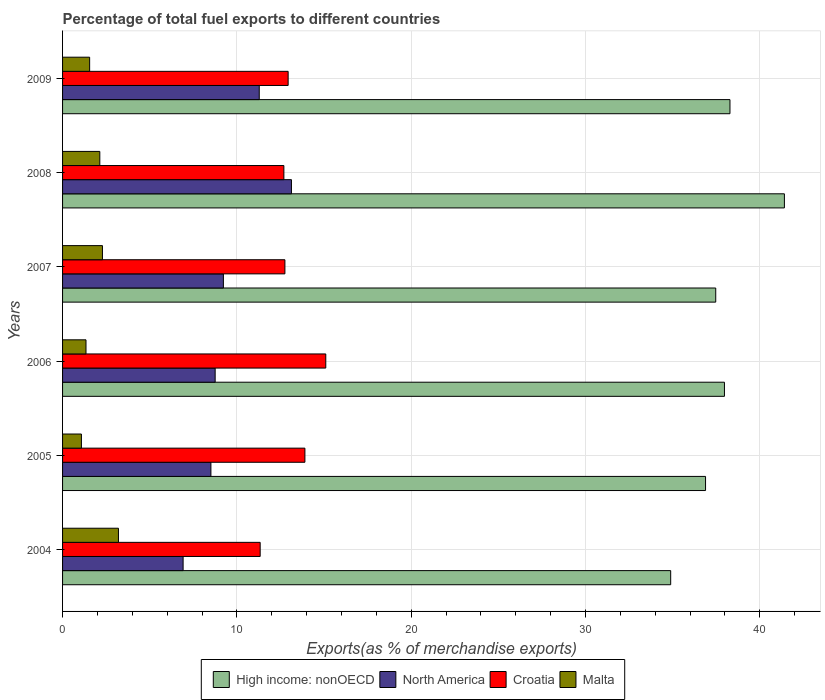How many different coloured bars are there?
Offer a terse response. 4. Are the number of bars per tick equal to the number of legend labels?
Your answer should be very brief. Yes. How many bars are there on the 2nd tick from the bottom?
Provide a short and direct response. 4. What is the percentage of exports to different countries in North America in 2006?
Your answer should be compact. 8.75. Across all years, what is the maximum percentage of exports to different countries in High income: nonOECD?
Offer a very short reply. 41.42. Across all years, what is the minimum percentage of exports to different countries in Malta?
Offer a terse response. 1.08. In which year was the percentage of exports to different countries in Croatia maximum?
Offer a very short reply. 2006. In which year was the percentage of exports to different countries in High income: nonOECD minimum?
Your answer should be very brief. 2004. What is the total percentage of exports to different countries in Croatia in the graph?
Offer a very short reply. 78.74. What is the difference between the percentage of exports to different countries in High income: nonOECD in 2005 and that in 2006?
Give a very brief answer. -1.08. What is the difference between the percentage of exports to different countries in High income: nonOECD in 2004 and the percentage of exports to different countries in Malta in 2007?
Offer a terse response. 32.6. What is the average percentage of exports to different countries in Croatia per year?
Your answer should be very brief. 13.12. In the year 2007, what is the difference between the percentage of exports to different countries in High income: nonOECD and percentage of exports to different countries in North America?
Offer a terse response. 28.25. What is the ratio of the percentage of exports to different countries in High income: nonOECD in 2004 to that in 2009?
Offer a very short reply. 0.91. Is the percentage of exports to different countries in North America in 2004 less than that in 2005?
Offer a terse response. Yes. Is the difference between the percentage of exports to different countries in High income: nonOECD in 2004 and 2005 greater than the difference between the percentage of exports to different countries in North America in 2004 and 2005?
Your answer should be very brief. No. What is the difference between the highest and the second highest percentage of exports to different countries in North America?
Provide a short and direct response. 1.85. What is the difference between the highest and the lowest percentage of exports to different countries in High income: nonOECD?
Keep it short and to the point. 6.52. What does the 2nd bar from the top in 2009 represents?
Your answer should be compact. Croatia. How many bars are there?
Give a very brief answer. 24. What is the difference between two consecutive major ticks on the X-axis?
Make the answer very short. 10. Are the values on the major ticks of X-axis written in scientific E-notation?
Ensure brevity in your answer.  No. Does the graph contain grids?
Give a very brief answer. Yes. What is the title of the graph?
Offer a very short reply. Percentage of total fuel exports to different countries. What is the label or title of the X-axis?
Give a very brief answer. Exports(as % of merchandise exports). What is the label or title of the Y-axis?
Offer a terse response. Years. What is the Exports(as % of merchandise exports) in High income: nonOECD in 2004?
Give a very brief answer. 34.89. What is the Exports(as % of merchandise exports) of North America in 2004?
Ensure brevity in your answer.  6.92. What is the Exports(as % of merchandise exports) in Croatia in 2004?
Your response must be concise. 11.34. What is the Exports(as % of merchandise exports) of Malta in 2004?
Your response must be concise. 3.21. What is the Exports(as % of merchandise exports) of High income: nonOECD in 2005?
Your answer should be very brief. 36.89. What is the Exports(as % of merchandise exports) of North America in 2005?
Your answer should be compact. 8.51. What is the Exports(as % of merchandise exports) of Croatia in 2005?
Your answer should be compact. 13.9. What is the Exports(as % of merchandise exports) of Malta in 2005?
Your answer should be very brief. 1.08. What is the Exports(as % of merchandise exports) of High income: nonOECD in 2006?
Ensure brevity in your answer.  37.98. What is the Exports(as % of merchandise exports) in North America in 2006?
Your response must be concise. 8.75. What is the Exports(as % of merchandise exports) of Croatia in 2006?
Provide a succinct answer. 15.1. What is the Exports(as % of merchandise exports) of Malta in 2006?
Offer a very short reply. 1.34. What is the Exports(as % of merchandise exports) of High income: nonOECD in 2007?
Offer a terse response. 37.48. What is the Exports(as % of merchandise exports) of North America in 2007?
Your answer should be very brief. 9.23. What is the Exports(as % of merchandise exports) in Croatia in 2007?
Offer a very short reply. 12.76. What is the Exports(as % of merchandise exports) in Malta in 2007?
Offer a very short reply. 2.29. What is the Exports(as % of merchandise exports) in High income: nonOECD in 2008?
Your response must be concise. 41.42. What is the Exports(as % of merchandise exports) in North America in 2008?
Provide a short and direct response. 13.13. What is the Exports(as % of merchandise exports) in Croatia in 2008?
Give a very brief answer. 12.7. What is the Exports(as % of merchandise exports) in Malta in 2008?
Give a very brief answer. 2.14. What is the Exports(as % of merchandise exports) in High income: nonOECD in 2009?
Offer a very short reply. 38.29. What is the Exports(as % of merchandise exports) in North America in 2009?
Your response must be concise. 11.28. What is the Exports(as % of merchandise exports) of Croatia in 2009?
Provide a short and direct response. 12.94. What is the Exports(as % of merchandise exports) in Malta in 2009?
Offer a very short reply. 1.55. Across all years, what is the maximum Exports(as % of merchandise exports) in High income: nonOECD?
Provide a short and direct response. 41.42. Across all years, what is the maximum Exports(as % of merchandise exports) in North America?
Your answer should be compact. 13.13. Across all years, what is the maximum Exports(as % of merchandise exports) in Croatia?
Your answer should be compact. 15.1. Across all years, what is the maximum Exports(as % of merchandise exports) of Malta?
Offer a very short reply. 3.21. Across all years, what is the minimum Exports(as % of merchandise exports) of High income: nonOECD?
Your answer should be compact. 34.89. Across all years, what is the minimum Exports(as % of merchandise exports) of North America?
Make the answer very short. 6.92. Across all years, what is the minimum Exports(as % of merchandise exports) in Croatia?
Your answer should be compact. 11.34. Across all years, what is the minimum Exports(as % of merchandise exports) in Malta?
Your answer should be very brief. 1.08. What is the total Exports(as % of merchandise exports) in High income: nonOECD in the graph?
Give a very brief answer. 226.94. What is the total Exports(as % of merchandise exports) of North America in the graph?
Your answer should be very brief. 57.83. What is the total Exports(as % of merchandise exports) of Croatia in the graph?
Provide a short and direct response. 78.74. What is the total Exports(as % of merchandise exports) in Malta in the graph?
Keep it short and to the point. 11.61. What is the difference between the Exports(as % of merchandise exports) of High income: nonOECD in 2004 and that in 2005?
Ensure brevity in your answer.  -2. What is the difference between the Exports(as % of merchandise exports) in North America in 2004 and that in 2005?
Give a very brief answer. -1.59. What is the difference between the Exports(as % of merchandise exports) in Croatia in 2004 and that in 2005?
Make the answer very short. -2.57. What is the difference between the Exports(as % of merchandise exports) of Malta in 2004 and that in 2005?
Your response must be concise. 2.13. What is the difference between the Exports(as % of merchandise exports) of High income: nonOECD in 2004 and that in 2006?
Your response must be concise. -3.08. What is the difference between the Exports(as % of merchandise exports) in North America in 2004 and that in 2006?
Your answer should be compact. -1.84. What is the difference between the Exports(as % of merchandise exports) in Croatia in 2004 and that in 2006?
Your answer should be compact. -3.77. What is the difference between the Exports(as % of merchandise exports) in Malta in 2004 and that in 2006?
Keep it short and to the point. 1.86. What is the difference between the Exports(as % of merchandise exports) of High income: nonOECD in 2004 and that in 2007?
Provide a succinct answer. -2.58. What is the difference between the Exports(as % of merchandise exports) of North America in 2004 and that in 2007?
Offer a terse response. -2.31. What is the difference between the Exports(as % of merchandise exports) in Croatia in 2004 and that in 2007?
Offer a very short reply. -1.42. What is the difference between the Exports(as % of merchandise exports) in Malta in 2004 and that in 2007?
Offer a terse response. 0.92. What is the difference between the Exports(as % of merchandise exports) in High income: nonOECD in 2004 and that in 2008?
Provide a succinct answer. -6.52. What is the difference between the Exports(as % of merchandise exports) of North America in 2004 and that in 2008?
Your response must be concise. -6.22. What is the difference between the Exports(as % of merchandise exports) of Croatia in 2004 and that in 2008?
Offer a terse response. -1.36. What is the difference between the Exports(as % of merchandise exports) of Malta in 2004 and that in 2008?
Provide a succinct answer. 1.07. What is the difference between the Exports(as % of merchandise exports) in High income: nonOECD in 2004 and that in 2009?
Offer a terse response. -3.4. What is the difference between the Exports(as % of merchandise exports) of North America in 2004 and that in 2009?
Provide a short and direct response. -4.37. What is the difference between the Exports(as % of merchandise exports) in Croatia in 2004 and that in 2009?
Provide a succinct answer. -1.6. What is the difference between the Exports(as % of merchandise exports) of Malta in 2004 and that in 2009?
Your answer should be very brief. 1.65. What is the difference between the Exports(as % of merchandise exports) in High income: nonOECD in 2005 and that in 2006?
Offer a terse response. -1.08. What is the difference between the Exports(as % of merchandise exports) in North America in 2005 and that in 2006?
Make the answer very short. -0.24. What is the difference between the Exports(as % of merchandise exports) of Croatia in 2005 and that in 2006?
Provide a succinct answer. -1.2. What is the difference between the Exports(as % of merchandise exports) of Malta in 2005 and that in 2006?
Your answer should be compact. -0.26. What is the difference between the Exports(as % of merchandise exports) of High income: nonOECD in 2005 and that in 2007?
Ensure brevity in your answer.  -0.58. What is the difference between the Exports(as % of merchandise exports) in North America in 2005 and that in 2007?
Provide a succinct answer. -0.72. What is the difference between the Exports(as % of merchandise exports) of Croatia in 2005 and that in 2007?
Ensure brevity in your answer.  1.15. What is the difference between the Exports(as % of merchandise exports) of Malta in 2005 and that in 2007?
Keep it short and to the point. -1.21. What is the difference between the Exports(as % of merchandise exports) in High income: nonOECD in 2005 and that in 2008?
Your answer should be compact. -4.52. What is the difference between the Exports(as % of merchandise exports) of North America in 2005 and that in 2008?
Your response must be concise. -4.62. What is the difference between the Exports(as % of merchandise exports) of Croatia in 2005 and that in 2008?
Provide a succinct answer. 1.21. What is the difference between the Exports(as % of merchandise exports) of Malta in 2005 and that in 2008?
Offer a very short reply. -1.06. What is the difference between the Exports(as % of merchandise exports) of High income: nonOECD in 2005 and that in 2009?
Offer a terse response. -1.4. What is the difference between the Exports(as % of merchandise exports) in North America in 2005 and that in 2009?
Ensure brevity in your answer.  -2.77. What is the difference between the Exports(as % of merchandise exports) in Croatia in 2005 and that in 2009?
Provide a succinct answer. 0.96. What is the difference between the Exports(as % of merchandise exports) of Malta in 2005 and that in 2009?
Offer a very short reply. -0.47. What is the difference between the Exports(as % of merchandise exports) of High income: nonOECD in 2006 and that in 2007?
Your response must be concise. 0.5. What is the difference between the Exports(as % of merchandise exports) in North America in 2006 and that in 2007?
Offer a terse response. -0.47. What is the difference between the Exports(as % of merchandise exports) of Croatia in 2006 and that in 2007?
Provide a succinct answer. 2.35. What is the difference between the Exports(as % of merchandise exports) of Malta in 2006 and that in 2007?
Make the answer very short. -0.94. What is the difference between the Exports(as % of merchandise exports) in High income: nonOECD in 2006 and that in 2008?
Your answer should be very brief. -3.44. What is the difference between the Exports(as % of merchandise exports) of North America in 2006 and that in 2008?
Keep it short and to the point. -4.38. What is the difference between the Exports(as % of merchandise exports) of Croatia in 2006 and that in 2008?
Offer a terse response. 2.4. What is the difference between the Exports(as % of merchandise exports) in Malta in 2006 and that in 2008?
Your answer should be very brief. -0.79. What is the difference between the Exports(as % of merchandise exports) in High income: nonOECD in 2006 and that in 2009?
Keep it short and to the point. -0.32. What is the difference between the Exports(as % of merchandise exports) of North America in 2006 and that in 2009?
Your answer should be very brief. -2.53. What is the difference between the Exports(as % of merchandise exports) of Croatia in 2006 and that in 2009?
Your response must be concise. 2.16. What is the difference between the Exports(as % of merchandise exports) of Malta in 2006 and that in 2009?
Ensure brevity in your answer.  -0.21. What is the difference between the Exports(as % of merchandise exports) of High income: nonOECD in 2007 and that in 2008?
Provide a succinct answer. -3.94. What is the difference between the Exports(as % of merchandise exports) of North America in 2007 and that in 2008?
Offer a terse response. -3.9. What is the difference between the Exports(as % of merchandise exports) of Croatia in 2007 and that in 2008?
Your answer should be very brief. 0.06. What is the difference between the Exports(as % of merchandise exports) in Malta in 2007 and that in 2008?
Provide a succinct answer. 0.15. What is the difference between the Exports(as % of merchandise exports) of High income: nonOECD in 2007 and that in 2009?
Make the answer very short. -0.82. What is the difference between the Exports(as % of merchandise exports) of North America in 2007 and that in 2009?
Keep it short and to the point. -2.06. What is the difference between the Exports(as % of merchandise exports) in Croatia in 2007 and that in 2009?
Offer a terse response. -0.19. What is the difference between the Exports(as % of merchandise exports) in Malta in 2007 and that in 2009?
Keep it short and to the point. 0.74. What is the difference between the Exports(as % of merchandise exports) in High income: nonOECD in 2008 and that in 2009?
Ensure brevity in your answer.  3.12. What is the difference between the Exports(as % of merchandise exports) of North America in 2008 and that in 2009?
Provide a succinct answer. 1.85. What is the difference between the Exports(as % of merchandise exports) in Croatia in 2008 and that in 2009?
Keep it short and to the point. -0.24. What is the difference between the Exports(as % of merchandise exports) of Malta in 2008 and that in 2009?
Offer a terse response. 0.58. What is the difference between the Exports(as % of merchandise exports) of High income: nonOECD in 2004 and the Exports(as % of merchandise exports) of North America in 2005?
Provide a short and direct response. 26.38. What is the difference between the Exports(as % of merchandise exports) in High income: nonOECD in 2004 and the Exports(as % of merchandise exports) in Croatia in 2005?
Your answer should be compact. 20.99. What is the difference between the Exports(as % of merchandise exports) in High income: nonOECD in 2004 and the Exports(as % of merchandise exports) in Malta in 2005?
Keep it short and to the point. 33.81. What is the difference between the Exports(as % of merchandise exports) of North America in 2004 and the Exports(as % of merchandise exports) of Croatia in 2005?
Ensure brevity in your answer.  -6.99. What is the difference between the Exports(as % of merchandise exports) in North America in 2004 and the Exports(as % of merchandise exports) in Malta in 2005?
Give a very brief answer. 5.83. What is the difference between the Exports(as % of merchandise exports) of Croatia in 2004 and the Exports(as % of merchandise exports) of Malta in 2005?
Offer a terse response. 10.26. What is the difference between the Exports(as % of merchandise exports) in High income: nonOECD in 2004 and the Exports(as % of merchandise exports) in North America in 2006?
Provide a succinct answer. 26.14. What is the difference between the Exports(as % of merchandise exports) in High income: nonOECD in 2004 and the Exports(as % of merchandise exports) in Croatia in 2006?
Provide a succinct answer. 19.79. What is the difference between the Exports(as % of merchandise exports) in High income: nonOECD in 2004 and the Exports(as % of merchandise exports) in Malta in 2006?
Ensure brevity in your answer.  33.55. What is the difference between the Exports(as % of merchandise exports) in North America in 2004 and the Exports(as % of merchandise exports) in Croatia in 2006?
Your response must be concise. -8.19. What is the difference between the Exports(as % of merchandise exports) in North America in 2004 and the Exports(as % of merchandise exports) in Malta in 2006?
Keep it short and to the point. 5.57. What is the difference between the Exports(as % of merchandise exports) of Croatia in 2004 and the Exports(as % of merchandise exports) of Malta in 2006?
Offer a very short reply. 9.99. What is the difference between the Exports(as % of merchandise exports) of High income: nonOECD in 2004 and the Exports(as % of merchandise exports) of North America in 2007?
Provide a succinct answer. 25.66. What is the difference between the Exports(as % of merchandise exports) of High income: nonOECD in 2004 and the Exports(as % of merchandise exports) of Croatia in 2007?
Ensure brevity in your answer.  22.14. What is the difference between the Exports(as % of merchandise exports) of High income: nonOECD in 2004 and the Exports(as % of merchandise exports) of Malta in 2007?
Give a very brief answer. 32.6. What is the difference between the Exports(as % of merchandise exports) of North America in 2004 and the Exports(as % of merchandise exports) of Croatia in 2007?
Keep it short and to the point. -5.84. What is the difference between the Exports(as % of merchandise exports) of North America in 2004 and the Exports(as % of merchandise exports) of Malta in 2007?
Provide a short and direct response. 4.63. What is the difference between the Exports(as % of merchandise exports) in Croatia in 2004 and the Exports(as % of merchandise exports) in Malta in 2007?
Keep it short and to the point. 9.05. What is the difference between the Exports(as % of merchandise exports) of High income: nonOECD in 2004 and the Exports(as % of merchandise exports) of North America in 2008?
Your response must be concise. 21.76. What is the difference between the Exports(as % of merchandise exports) of High income: nonOECD in 2004 and the Exports(as % of merchandise exports) of Croatia in 2008?
Ensure brevity in your answer.  22.19. What is the difference between the Exports(as % of merchandise exports) in High income: nonOECD in 2004 and the Exports(as % of merchandise exports) in Malta in 2008?
Ensure brevity in your answer.  32.75. What is the difference between the Exports(as % of merchandise exports) in North America in 2004 and the Exports(as % of merchandise exports) in Croatia in 2008?
Provide a short and direct response. -5.78. What is the difference between the Exports(as % of merchandise exports) of North America in 2004 and the Exports(as % of merchandise exports) of Malta in 2008?
Give a very brief answer. 4.78. What is the difference between the Exports(as % of merchandise exports) in Croatia in 2004 and the Exports(as % of merchandise exports) in Malta in 2008?
Give a very brief answer. 9.2. What is the difference between the Exports(as % of merchandise exports) of High income: nonOECD in 2004 and the Exports(as % of merchandise exports) of North America in 2009?
Offer a terse response. 23.61. What is the difference between the Exports(as % of merchandise exports) in High income: nonOECD in 2004 and the Exports(as % of merchandise exports) in Croatia in 2009?
Keep it short and to the point. 21.95. What is the difference between the Exports(as % of merchandise exports) of High income: nonOECD in 2004 and the Exports(as % of merchandise exports) of Malta in 2009?
Your response must be concise. 33.34. What is the difference between the Exports(as % of merchandise exports) of North America in 2004 and the Exports(as % of merchandise exports) of Croatia in 2009?
Give a very brief answer. -6.03. What is the difference between the Exports(as % of merchandise exports) in North America in 2004 and the Exports(as % of merchandise exports) in Malta in 2009?
Provide a short and direct response. 5.36. What is the difference between the Exports(as % of merchandise exports) of Croatia in 2004 and the Exports(as % of merchandise exports) of Malta in 2009?
Your answer should be very brief. 9.78. What is the difference between the Exports(as % of merchandise exports) of High income: nonOECD in 2005 and the Exports(as % of merchandise exports) of North America in 2006?
Your response must be concise. 28.14. What is the difference between the Exports(as % of merchandise exports) in High income: nonOECD in 2005 and the Exports(as % of merchandise exports) in Croatia in 2006?
Offer a terse response. 21.79. What is the difference between the Exports(as % of merchandise exports) of High income: nonOECD in 2005 and the Exports(as % of merchandise exports) of Malta in 2006?
Give a very brief answer. 35.55. What is the difference between the Exports(as % of merchandise exports) of North America in 2005 and the Exports(as % of merchandise exports) of Croatia in 2006?
Provide a succinct answer. -6.59. What is the difference between the Exports(as % of merchandise exports) of North America in 2005 and the Exports(as % of merchandise exports) of Malta in 2006?
Make the answer very short. 7.17. What is the difference between the Exports(as % of merchandise exports) in Croatia in 2005 and the Exports(as % of merchandise exports) in Malta in 2006?
Provide a short and direct response. 12.56. What is the difference between the Exports(as % of merchandise exports) in High income: nonOECD in 2005 and the Exports(as % of merchandise exports) in North America in 2007?
Make the answer very short. 27.66. What is the difference between the Exports(as % of merchandise exports) of High income: nonOECD in 2005 and the Exports(as % of merchandise exports) of Croatia in 2007?
Your response must be concise. 24.13. What is the difference between the Exports(as % of merchandise exports) of High income: nonOECD in 2005 and the Exports(as % of merchandise exports) of Malta in 2007?
Offer a terse response. 34.6. What is the difference between the Exports(as % of merchandise exports) in North America in 2005 and the Exports(as % of merchandise exports) in Croatia in 2007?
Provide a succinct answer. -4.25. What is the difference between the Exports(as % of merchandise exports) in North America in 2005 and the Exports(as % of merchandise exports) in Malta in 2007?
Your answer should be compact. 6.22. What is the difference between the Exports(as % of merchandise exports) in Croatia in 2005 and the Exports(as % of merchandise exports) in Malta in 2007?
Your answer should be compact. 11.62. What is the difference between the Exports(as % of merchandise exports) of High income: nonOECD in 2005 and the Exports(as % of merchandise exports) of North America in 2008?
Provide a short and direct response. 23.76. What is the difference between the Exports(as % of merchandise exports) of High income: nonOECD in 2005 and the Exports(as % of merchandise exports) of Croatia in 2008?
Keep it short and to the point. 24.19. What is the difference between the Exports(as % of merchandise exports) in High income: nonOECD in 2005 and the Exports(as % of merchandise exports) in Malta in 2008?
Offer a very short reply. 34.75. What is the difference between the Exports(as % of merchandise exports) in North America in 2005 and the Exports(as % of merchandise exports) in Croatia in 2008?
Your response must be concise. -4.19. What is the difference between the Exports(as % of merchandise exports) of North America in 2005 and the Exports(as % of merchandise exports) of Malta in 2008?
Your answer should be compact. 6.37. What is the difference between the Exports(as % of merchandise exports) in Croatia in 2005 and the Exports(as % of merchandise exports) in Malta in 2008?
Your answer should be very brief. 11.77. What is the difference between the Exports(as % of merchandise exports) in High income: nonOECD in 2005 and the Exports(as % of merchandise exports) in North America in 2009?
Ensure brevity in your answer.  25.61. What is the difference between the Exports(as % of merchandise exports) of High income: nonOECD in 2005 and the Exports(as % of merchandise exports) of Croatia in 2009?
Provide a short and direct response. 23.95. What is the difference between the Exports(as % of merchandise exports) of High income: nonOECD in 2005 and the Exports(as % of merchandise exports) of Malta in 2009?
Offer a very short reply. 35.34. What is the difference between the Exports(as % of merchandise exports) of North America in 2005 and the Exports(as % of merchandise exports) of Croatia in 2009?
Keep it short and to the point. -4.43. What is the difference between the Exports(as % of merchandise exports) in North America in 2005 and the Exports(as % of merchandise exports) in Malta in 2009?
Ensure brevity in your answer.  6.96. What is the difference between the Exports(as % of merchandise exports) in Croatia in 2005 and the Exports(as % of merchandise exports) in Malta in 2009?
Ensure brevity in your answer.  12.35. What is the difference between the Exports(as % of merchandise exports) of High income: nonOECD in 2006 and the Exports(as % of merchandise exports) of North America in 2007?
Provide a short and direct response. 28.75. What is the difference between the Exports(as % of merchandise exports) of High income: nonOECD in 2006 and the Exports(as % of merchandise exports) of Croatia in 2007?
Keep it short and to the point. 25.22. What is the difference between the Exports(as % of merchandise exports) of High income: nonOECD in 2006 and the Exports(as % of merchandise exports) of Malta in 2007?
Offer a very short reply. 35.69. What is the difference between the Exports(as % of merchandise exports) in North America in 2006 and the Exports(as % of merchandise exports) in Croatia in 2007?
Ensure brevity in your answer.  -4. What is the difference between the Exports(as % of merchandise exports) of North America in 2006 and the Exports(as % of merchandise exports) of Malta in 2007?
Provide a succinct answer. 6.47. What is the difference between the Exports(as % of merchandise exports) of Croatia in 2006 and the Exports(as % of merchandise exports) of Malta in 2007?
Provide a short and direct response. 12.81. What is the difference between the Exports(as % of merchandise exports) in High income: nonOECD in 2006 and the Exports(as % of merchandise exports) in North America in 2008?
Provide a short and direct response. 24.84. What is the difference between the Exports(as % of merchandise exports) of High income: nonOECD in 2006 and the Exports(as % of merchandise exports) of Croatia in 2008?
Give a very brief answer. 25.28. What is the difference between the Exports(as % of merchandise exports) of High income: nonOECD in 2006 and the Exports(as % of merchandise exports) of Malta in 2008?
Ensure brevity in your answer.  35.84. What is the difference between the Exports(as % of merchandise exports) in North America in 2006 and the Exports(as % of merchandise exports) in Croatia in 2008?
Your response must be concise. -3.94. What is the difference between the Exports(as % of merchandise exports) of North America in 2006 and the Exports(as % of merchandise exports) of Malta in 2008?
Your response must be concise. 6.62. What is the difference between the Exports(as % of merchandise exports) of Croatia in 2006 and the Exports(as % of merchandise exports) of Malta in 2008?
Offer a terse response. 12.97. What is the difference between the Exports(as % of merchandise exports) of High income: nonOECD in 2006 and the Exports(as % of merchandise exports) of North America in 2009?
Provide a succinct answer. 26.69. What is the difference between the Exports(as % of merchandise exports) in High income: nonOECD in 2006 and the Exports(as % of merchandise exports) in Croatia in 2009?
Your response must be concise. 25.03. What is the difference between the Exports(as % of merchandise exports) in High income: nonOECD in 2006 and the Exports(as % of merchandise exports) in Malta in 2009?
Make the answer very short. 36.42. What is the difference between the Exports(as % of merchandise exports) of North America in 2006 and the Exports(as % of merchandise exports) of Croatia in 2009?
Your answer should be very brief. -4.19. What is the difference between the Exports(as % of merchandise exports) of North America in 2006 and the Exports(as % of merchandise exports) of Malta in 2009?
Keep it short and to the point. 7.2. What is the difference between the Exports(as % of merchandise exports) in Croatia in 2006 and the Exports(as % of merchandise exports) in Malta in 2009?
Provide a short and direct response. 13.55. What is the difference between the Exports(as % of merchandise exports) of High income: nonOECD in 2007 and the Exports(as % of merchandise exports) of North America in 2008?
Your answer should be compact. 24.34. What is the difference between the Exports(as % of merchandise exports) of High income: nonOECD in 2007 and the Exports(as % of merchandise exports) of Croatia in 2008?
Your answer should be very brief. 24.78. What is the difference between the Exports(as % of merchandise exports) of High income: nonOECD in 2007 and the Exports(as % of merchandise exports) of Malta in 2008?
Your answer should be compact. 35.34. What is the difference between the Exports(as % of merchandise exports) of North America in 2007 and the Exports(as % of merchandise exports) of Croatia in 2008?
Offer a terse response. -3.47. What is the difference between the Exports(as % of merchandise exports) of North America in 2007 and the Exports(as % of merchandise exports) of Malta in 2008?
Ensure brevity in your answer.  7.09. What is the difference between the Exports(as % of merchandise exports) in Croatia in 2007 and the Exports(as % of merchandise exports) in Malta in 2008?
Keep it short and to the point. 10.62. What is the difference between the Exports(as % of merchandise exports) of High income: nonOECD in 2007 and the Exports(as % of merchandise exports) of North America in 2009?
Give a very brief answer. 26.19. What is the difference between the Exports(as % of merchandise exports) in High income: nonOECD in 2007 and the Exports(as % of merchandise exports) in Croatia in 2009?
Ensure brevity in your answer.  24.53. What is the difference between the Exports(as % of merchandise exports) of High income: nonOECD in 2007 and the Exports(as % of merchandise exports) of Malta in 2009?
Make the answer very short. 35.92. What is the difference between the Exports(as % of merchandise exports) of North America in 2007 and the Exports(as % of merchandise exports) of Croatia in 2009?
Your answer should be very brief. -3.71. What is the difference between the Exports(as % of merchandise exports) in North America in 2007 and the Exports(as % of merchandise exports) in Malta in 2009?
Provide a succinct answer. 7.67. What is the difference between the Exports(as % of merchandise exports) in Croatia in 2007 and the Exports(as % of merchandise exports) in Malta in 2009?
Make the answer very short. 11.2. What is the difference between the Exports(as % of merchandise exports) in High income: nonOECD in 2008 and the Exports(as % of merchandise exports) in North America in 2009?
Give a very brief answer. 30.13. What is the difference between the Exports(as % of merchandise exports) in High income: nonOECD in 2008 and the Exports(as % of merchandise exports) in Croatia in 2009?
Ensure brevity in your answer.  28.47. What is the difference between the Exports(as % of merchandise exports) in High income: nonOECD in 2008 and the Exports(as % of merchandise exports) in Malta in 2009?
Provide a succinct answer. 39.86. What is the difference between the Exports(as % of merchandise exports) of North America in 2008 and the Exports(as % of merchandise exports) of Croatia in 2009?
Provide a short and direct response. 0.19. What is the difference between the Exports(as % of merchandise exports) of North America in 2008 and the Exports(as % of merchandise exports) of Malta in 2009?
Make the answer very short. 11.58. What is the difference between the Exports(as % of merchandise exports) of Croatia in 2008 and the Exports(as % of merchandise exports) of Malta in 2009?
Offer a very short reply. 11.14. What is the average Exports(as % of merchandise exports) in High income: nonOECD per year?
Ensure brevity in your answer.  37.82. What is the average Exports(as % of merchandise exports) of North America per year?
Provide a succinct answer. 9.64. What is the average Exports(as % of merchandise exports) in Croatia per year?
Provide a succinct answer. 13.12. What is the average Exports(as % of merchandise exports) in Malta per year?
Give a very brief answer. 1.94. In the year 2004, what is the difference between the Exports(as % of merchandise exports) of High income: nonOECD and Exports(as % of merchandise exports) of North America?
Your answer should be very brief. 27.98. In the year 2004, what is the difference between the Exports(as % of merchandise exports) of High income: nonOECD and Exports(as % of merchandise exports) of Croatia?
Provide a succinct answer. 23.55. In the year 2004, what is the difference between the Exports(as % of merchandise exports) in High income: nonOECD and Exports(as % of merchandise exports) in Malta?
Provide a short and direct response. 31.69. In the year 2004, what is the difference between the Exports(as % of merchandise exports) in North America and Exports(as % of merchandise exports) in Croatia?
Provide a short and direct response. -4.42. In the year 2004, what is the difference between the Exports(as % of merchandise exports) of North America and Exports(as % of merchandise exports) of Malta?
Provide a short and direct response. 3.71. In the year 2004, what is the difference between the Exports(as % of merchandise exports) of Croatia and Exports(as % of merchandise exports) of Malta?
Your answer should be very brief. 8.13. In the year 2005, what is the difference between the Exports(as % of merchandise exports) in High income: nonOECD and Exports(as % of merchandise exports) in North America?
Your answer should be compact. 28.38. In the year 2005, what is the difference between the Exports(as % of merchandise exports) in High income: nonOECD and Exports(as % of merchandise exports) in Croatia?
Provide a short and direct response. 22.99. In the year 2005, what is the difference between the Exports(as % of merchandise exports) in High income: nonOECD and Exports(as % of merchandise exports) in Malta?
Ensure brevity in your answer.  35.81. In the year 2005, what is the difference between the Exports(as % of merchandise exports) of North America and Exports(as % of merchandise exports) of Croatia?
Keep it short and to the point. -5.39. In the year 2005, what is the difference between the Exports(as % of merchandise exports) in North America and Exports(as % of merchandise exports) in Malta?
Ensure brevity in your answer.  7.43. In the year 2005, what is the difference between the Exports(as % of merchandise exports) in Croatia and Exports(as % of merchandise exports) in Malta?
Your answer should be compact. 12.82. In the year 2006, what is the difference between the Exports(as % of merchandise exports) of High income: nonOECD and Exports(as % of merchandise exports) of North America?
Your response must be concise. 29.22. In the year 2006, what is the difference between the Exports(as % of merchandise exports) of High income: nonOECD and Exports(as % of merchandise exports) of Croatia?
Provide a succinct answer. 22.87. In the year 2006, what is the difference between the Exports(as % of merchandise exports) of High income: nonOECD and Exports(as % of merchandise exports) of Malta?
Offer a terse response. 36.63. In the year 2006, what is the difference between the Exports(as % of merchandise exports) of North America and Exports(as % of merchandise exports) of Croatia?
Ensure brevity in your answer.  -6.35. In the year 2006, what is the difference between the Exports(as % of merchandise exports) in North America and Exports(as % of merchandise exports) in Malta?
Your answer should be compact. 7.41. In the year 2006, what is the difference between the Exports(as % of merchandise exports) of Croatia and Exports(as % of merchandise exports) of Malta?
Ensure brevity in your answer.  13.76. In the year 2007, what is the difference between the Exports(as % of merchandise exports) of High income: nonOECD and Exports(as % of merchandise exports) of North America?
Make the answer very short. 28.25. In the year 2007, what is the difference between the Exports(as % of merchandise exports) in High income: nonOECD and Exports(as % of merchandise exports) in Croatia?
Give a very brief answer. 24.72. In the year 2007, what is the difference between the Exports(as % of merchandise exports) of High income: nonOECD and Exports(as % of merchandise exports) of Malta?
Give a very brief answer. 35.19. In the year 2007, what is the difference between the Exports(as % of merchandise exports) of North America and Exports(as % of merchandise exports) of Croatia?
Keep it short and to the point. -3.53. In the year 2007, what is the difference between the Exports(as % of merchandise exports) of North America and Exports(as % of merchandise exports) of Malta?
Keep it short and to the point. 6.94. In the year 2007, what is the difference between the Exports(as % of merchandise exports) of Croatia and Exports(as % of merchandise exports) of Malta?
Offer a terse response. 10.47. In the year 2008, what is the difference between the Exports(as % of merchandise exports) of High income: nonOECD and Exports(as % of merchandise exports) of North America?
Ensure brevity in your answer.  28.28. In the year 2008, what is the difference between the Exports(as % of merchandise exports) of High income: nonOECD and Exports(as % of merchandise exports) of Croatia?
Make the answer very short. 28.72. In the year 2008, what is the difference between the Exports(as % of merchandise exports) in High income: nonOECD and Exports(as % of merchandise exports) in Malta?
Keep it short and to the point. 39.28. In the year 2008, what is the difference between the Exports(as % of merchandise exports) of North America and Exports(as % of merchandise exports) of Croatia?
Offer a terse response. 0.43. In the year 2008, what is the difference between the Exports(as % of merchandise exports) in North America and Exports(as % of merchandise exports) in Malta?
Provide a succinct answer. 11. In the year 2008, what is the difference between the Exports(as % of merchandise exports) in Croatia and Exports(as % of merchandise exports) in Malta?
Provide a short and direct response. 10.56. In the year 2009, what is the difference between the Exports(as % of merchandise exports) of High income: nonOECD and Exports(as % of merchandise exports) of North America?
Keep it short and to the point. 27.01. In the year 2009, what is the difference between the Exports(as % of merchandise exports) in High income: nonOECD and Exports(as % of merchandise exports) in Croatia?
Keep it short and to the point. 25.35. In the year 2009, what is the difference between the Exports(as % of merchandise exports) of High income: nonOECD and Exports(as % of merchandise exports) of Malta?
Your answer should be very brief. 36.74. In the year 2009, what is the difference between the Exports(as % of merchandise exports) in North America and Exports(as % of merchandise exports) in Croatia?
Offer a terse response. -1.66. In the year 2009, what is the difference between the Exports(as % of merchandise exports) in North America and Exports(as % of merchandise exports) in Malta?
Your answer should be compact. 9.73. In the year 2009, what is the difference between the Exports(as % of merchandise exports) of Croatia and Exports(as % of merchandise exports) of Malta?
Provide a short and direct response. 11.39. What is the ratio of the Exports(as % of merchandise exports) in High income: nonOECD in 2004 to that in 2005?
Your answer should be very brief. 0.95. What is the ratio of the Exports(as % of merchandise exports) of North America in 2004 to that in 2005?
Provide a short and direct response. 0.81. What is the ratio of the Exports(as % of merchandise exports) in Croatia in 2004 to that in 2005?
Offer a very short reply. 0.82. What is the ratio of the Exports(as % of merchandise exports) in Malta in 2004 to that in 2005?
Provide a short and direct response. 2.96. What is the ratio of the Exports(as % of merchandise exports) in High income: nonOECD in 2004 to that in 2006?
Provide a succinct answer. 0.92. What is the ratio of the Exports(as % of merchandise exports) of North America in 2004 to that in 2006?
Provide a succinct answer. 0.79. What is the ratio of the Exports(as % of merchandise exports) in Croatia in 2004 to that in 2006?
Make the answer very short. 0.75. What is the ratio of the Exports(as % of merchandise exports) in Malta in 2004 to that in 2006?
Your answer should be very brief. 2.38. What is the ratio of the Exports(as % of merchandise exports) in High income: nonOECD in 2004 to that in 2007?
Give a very brief answer. 0.93. What is the ratio of the Exports(as % of merchandise exports) in North America in 2004 to that in 2007?
Make the answer very short. 0.75. What is the ratio of the Exports(as % of merchandise exports) in Croatia in 2004 to that in 2007?
Keep it short and to the point. 0.89. What is the ratio of the Exports(as % of merchandise exports) in Malta in 2004 to that in 2007?
Your answer should be compact. 1.4. What is the ratio of the Exports(as % of merchandise exports) of High income: nonOECD in 2004 to that in 2008?
Make the answer very short. 0.84. What is the ratio of the Exports(as % of merchandise exports) of North America in 2004 to that in 2008?
Make the answer very short. 0.53. What is the ratio of the Exports(as % of merchandise exports) of Croatia in 2004 to that in 2008?
Keep it short and to the point. 0.89. What is the ratio of the Exports(as % of merchandise exports) of Malta in 2004 to that in 2008?
Keep it short and to the point. 1.5. What is the ratio of the Exports(as % of merchandise exports) in High income: nonOECD in 2004 to that in 2009?
Provide a succinct answer. 0.91. What is the ratio of the Exports(as % of merchandise exports) of North America in 2004 to that in 2009?
Provide a short and direct response. 0.61. What is the ratio of the Exports(as % of merchandise exports) in Croatia in 2004 to that in 2009?
Provide a succinct answer. 0.88. What is the ratio of the Exports(as % of merchandise exports) in Malta in 2004 to that in 2009?
Offer a terse response. 2.06. What is the ratio of the Exports(as % of merchandise exports) of High income: nonOECD in 2005 to that in 2006?
Your answer should be very brief. 0.97. What is the ratio of the Exports(as % of merchandise exports) in North America in 2005 to that in 2006?
Keep it short and to the point. 0.97. What is the ratio of the Exports(as % of merchandise exports) of Croatia in 2005 to that in 2006?
Offer a very short reply. 0.92. What is the ratio of the Exports(as % of merchandise exports) in Malta in 2005 to that in 2006?
Provide a short and direct response. 0.8. What is the ratio of the Exports(as % of merchandise exports) of High income: nonOECD in 2005 to that in 2007?
Keep it short and to the point. 0.98. What is the ratio of the Exports(as % of merchandise exports) of North America in 2005 to that in 2007?
Offer a very short reply. 0.92. What is the ratio of the Exports(as % of merchandise exports) in Croatia in 2005 to that in 2007?
Give a very brief answer. 1.09. What is the ratio of the Exports(as % of merchandise exports) of Malta in 2005 to that in 2007?
Ensure brevity in your answer.  0.47. What is the ratio of the Exports(as % of merchandise exports) in High income: nonOECD in 2005 to that in 2008?
Keep it short and to the point. 0.89. What is the ratio of the Exports(as % of merchandise exports) of North America in 2005 to that in 2008?
Provide a short and direct response. 0.65. What is the ratio of the Exports(as % of merchandise exports) of Croatia in 2005 to that in 2008?
Your answer should be very brief. 1.09. What is the ratio of the Exports(as % of merchandise exports) of Malta in 2005 to that in 2008?
Make the answer very short. 0.51. What is the ratio of the Exports(as % of merchandise exports) in High income: nonOECD in 2005 to that in 2009?
Your answer should be very brief. 0.96. What is the ratio of the Exports(as % of merchandise exports) in North America in 2005 to that in 2009?
Provide a succinct answer. 0.75. What is the ratio of the Exports(as % of merchandise exports) of Croatia in 2005 to that in 2009?
Offer a terse response. 1.07. What is the ratio of the Exports(as % of merchandise exports) in Malta in 2005 to that in 2009?
Provide a succinct answer. 0.7. What is the ratio of the Exports(as % of merchandise exports) in High income: nonOECD in 2006 to that in 2007?
Provide a short and direct response. 1.01. What is the ratio of the Exports(as % of merchandise exports) of North America in 2006 to that in 2007?
Make the answer very short. 0.95. What is the ratio of the Exports(as % of merchandise exports) of Croatia in 2006 to that in 2007?
Your answer should be very brief. 1.18. What is the ratio of the Exports(as % of merchandise exports) of Malta in 2006 to that in 2007?
Offer a terse response. 0.59. What is the ratio of the Exports(as % of merchandise exports) in High income: nonOECD in 2006 to that in 2008?
Provide a succinct answer. 0.92. What is the ratio of the Exports(as % of merchandise exports) in Croatia in 2006 to that in 2008?
Ensure brevity in your answer.  1.19. What is the ratio of the Exports(as % of merchandise exports) of Malta in 2006 to that in 2008?
Ensure brevity in your answer.  0.63. What is the ratio of the Exports(as % of merchandise exports) of North America in 2006 to that in 2009?
Offer a very short reply. 0.78. What is the ratio of the Exports(as % of merchandise exports) in Croatia in 2006 to that in 2009?
Keep it short and to the point. 1.17. What is the ratio of the Exports(as % of merchandise exports) in Malta in 2006 to that in 2009?
Make the answer very short. 0.87. What is the ratio of the Exports(as % of merchandise exports) of High income: nonOECD in 2007 to that in 2008?
Offer a very short reply. 0.9. What is the ratio of the Exports(as % of merchandise exports) in North America in 2007 to that in 2008?
Your response must be concise. 0.7. What is the ratio of the Exports(as % of merchandise exports) of Croatia in 2007 to that in 2008?
Give a very brief answer. 1. What is the ratio of the Exports(as % of merchandise exports) of Malta in 2007 to that in 2008?
Provide a short and direct response. 1.07. What is the ratio of the Exports(as % of merchandise exports) of High income: nonOECD in 2007 to that in 2009?
Your answer should be very brief. 0.98. What is the ratio of the Exports(as % of merchandise exports) of North America in 2007 to that in 2009?
Offer a very short reply. 0.82. What is the ratio of the Exports(as % of merchandise exports) of Croatia in 2007 to that in 2009?
Your answer should be very brief. 0.99. What is the ratio of the Exports(as % of merchandise exports) in Malta in 2007 to that in 2009?
Provide a short and direct response. 1.47. What is the ratio of the Exports(as % of merchandise exports) of High income: nonOECD in 2008 to that in 2009?
Give a very brief answer. 1.08. What is the ratio of the Exports(as % of merchandise exports) in North America in 2008 to that in 2009?
Provide a succinct answer. 1.16. What is the ratio of the Exports(as % of merchandise exports) in Croatia in 2008 to that in 2009?
Keep it short and to the point. 0.98. What is the ratio of the Exports(as % of merchandise exports) of Malta in 2008 to that in 2009?
Keep it short and to the point. 1.38. What is the difference between the highest and the second highest Exports(as % of merchandise exports) in High income: nonOECD?
Offer a very short reply. 3.12. What is the difference between the highest and the second highest Exports(as % of merchandise exports) in North America?
Your answer should be compact. 1.85. What is the difference between the highest and the second highest Exports(as % of merchandise exports) in Croatia?
Your response must be concise. 1.2. What is the difference between the highest and the second highest Exports(as % of merchandise exports) of Malta?
Your answer should be very brief. 0.92. What is the difference between the highest and the lowest Exports(as % of merchandise exports) in High income: nonOECD?
Your answer should be very brief. 6.52. What is the difference between the highest and the lowest Exports(as % of merchandise exports) of North America?
Give a very brief answer. 6.22. What is the difference between the highest and the lowest Exports(as % of merchandise exports) of Croatia?
Your answer should be compact. 3.77. What is the difference between the highest and the lowest Exports(as % of merchandise exports) of Malta?
Your answer should be very brief. 2.13. 